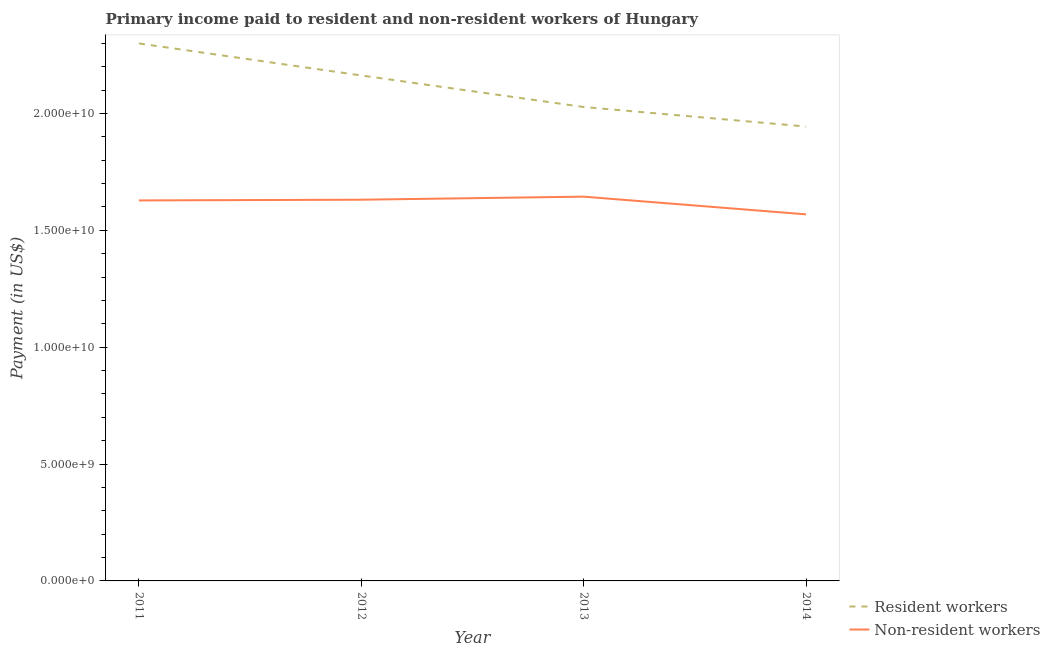Does the line corresponding to payment made to non-resident workers intersect with the line corresponding to payment made to resident workers?
Provide a succinct answer. No. What is the payment made to resident workers in 2011?
Provide a short and direct response. 2.30e+1. Across all years, what is the maximum payment made to resident workers?
Provide a succinct answer. 2.30e+1. Across all years, what is the minimum payment made to resident workers?
Keep it short and to the point. 1.94e+1. In which year was the payment made to resident workers maximum?
Your answer should be compact. 2011. In which year was the payment made to resident workers minimum?
Give a very brief answer. 2014. What is the total payment made to resident workers in the graph?
Give a very brief answer. 8.43e+1. What is the difference between the payment made to resident workers in 2012 and that in 2013?
Keep it short and to the point. 1.35e+09. What is the difference between the payment made to non-resident workers in 2014 and the payment made to resident workers in 2012?
Offer a very short reply. -5.94e+09. What is the average payment made to resident workers per year?
Provide a succinct answer. 2.11e+1. In the year 2014, what is the difference between the payment made to resident workers and payment made to non-resident workers?
Keep it short and to the point. 3.76e+09. What is the ratio of the payment made to non-resident workers in 2013 to that in 2014?
Give a very brief answer. 1.05. What is the difference between the highest and the second highest payment made to non-resident workers?
Offer a terse response. 1.30e+08. What is the difference between the highest and the lowest payment made to resident workers?
Offer a terse response. 3.56e+09. Is the sum of the payment made to resident workers in 2013 and 2014 greater than the maximum payment made to non-resident workers across all years?
Your answer should be compact. Yes. Is the payment made to resident workers strictly greater than the payment made to non-resident workers over the years?
Ensure brevity in your answer.  Yes. Is the payment made to resident workers strictly less than the payment made to non-resident workers over the years?
Your response must be concise. No. How many lines are there?
Give a very brief answer. 2. What is the difference between two consecutive major ticks on the Y-axis?
Offer a terse response. 5.00e+09. Does the graph contain any zero values?
Ensure brevity in your answer.  No. Does the graph contain grids?
Give a very brief answer. No. How are the legend labels stacked?
Offer a very short reply. Vertical. What is the title of the graph?
Offer a terse response. Primary income paid to resident and non-resident workers of Hungary. Does "Central government" appear as one of the legend labels in the graph?
Give a very brief answer. No. What is the label or title of the X-axis?
Provide a succinct answer. Year. What is the label or title of the Y-axis?
Offer a terse response. Payment (in US$). What is the Payment (in US$) of Resident workers in 2011?
Your answer should be very brief. 2.30e+1. What is the Payment (in US$) of Non-resident workers in 2011?
Your answer should be very brief. 1.63e+1. What is the Payment (in US$) in Resident workers in 2012?
Give a very brief answer. 2.16e+1. What is the Payment (in US$) in Non-resident workers in 2012?
Offer a terse response. 1.63e+1. What is the Payment (in US$) in Resident workers in 2013?
Provide a succinct answer. 2.03e+1. What is the Payment (in US$) of Non-resident workers in 2013?
Your response must be concise. 1.64e+1. What is the Payment (in US$) in Resident workers in 2014?
Offer a very short reply. 1.94e+1. What is the Payment (in US$) of Non-resident workers in 2014?
Offer a very short reply. 1.57e+1. Across all years, what is the maximum Payment (in US$) of Resident workers?
Your answer should be very brief. 2.30e+1. Across all years, what is the maximum Payment (in US$) of Non-resident workers?
Keep it short and to the point. 1.64e+1. Across all years, what is the minimum Payment (in US$) in Resident workers?
Provide a short and direct response. 1.94e+1. Across all years, what is the minimum Payment (in US$) of Non-resident workers?
Ensure brevity in your answer.  1.57e+1. What is the total Payment (in US$) in Resident workers in the graph?
Your answer should be compact. 8.43e+1. What is the total Payment (in US$) of Non-resident workers in the graph?
Your answer should be compact. 6.47e+1. What is the difference between the Payment (in US$) of Resident workers in 2011 and that in 2012?
Make the answer very short. 1.37e+09. What is the difference between the Payment (in US$) of Non-resident workers in 2011 and that in 2012?
Your answer should be compact. -3.10e+07. What is the difference between the Payment (in US$) of Resident workers in 2011 and that in 2013?
Offer a very short reply. 2.72e+09. What is the difference between the Payment (in US$) of Non-resident workers in 2011 and that in 2013?
Your answer should be very brief. -1.61e+08. What is the difference between the Payment (in US$) in Resident workers in 2011 and that in 2014?
Give a very brief answer. 3.56e+09. What is the difference between the Payment (in US$) in Non-resident workers in 2011 and that in 2014?
Keep it short and to the point. 5.96e+08. What is the difference between the Payment (in US$) of Resident workers in 2012 and that in 2013?
Offer a terse response. 1.35e+09. What is the difference between the Payment (in US$) in Non-resident workers in 2012 and that in 2013?
Your answer should be very brief. -1.30e+08. What is the difference between the Payment (in US$) in Resident workers in 2012 and that in 2014?
Your answer should be very brief. 2.19e+09. What is the difference between the Payment (in US$) of Non-resident workers in 2012 and that in 2014?
Your response must be concise. 6.27e+08. What is the difference between the Payment (in US$) of Resident workers in 2013 and that in 2014?
Ensure brevity in your answer.  8.36e+08. What is the difference between the Payment (in US$) of Non-resident workers in 2013 and that in 2014?
Keep it short and to the point. 7.57e+08. What is the difference between the Payment (in US$) of Resident workers in 2011 and the Payment (in US$) of Non-resident workers in 2012?
Give a very brief answer. 6.69e+09. What is the difference between the Payment (in US$) of Resident workers in 2011 and the Payment (in US$) of Non-resident workers in 2013?
Keep it short and to the point. 6.56e+09. What is the difference between the Payment (in US$) of Resident workers in 2011 and the Payment (in US$) of Non-resident workers in 2014?
Your response must be concise. 7.31e+09. What is the difference between the Payment (in US$) in Resident workers in 2012 and the Payment (in US$) in Non-resident workers in 2013?
Offer a very short reply. 5.19e+09. What is the difference between the Payment (in US$) of Resident workers in 2012 and the Payment (in US$) of Non-resident workers in 2014?
Give a very brief answer. 5.94e+09. What is the difference between the Payment (in US$) in Resident workers in 2013 and the Payment (in US$) in Non-resident workers in 2014?
Make the answer very short. 4.59e+09. What is the average Payment (in US$) in Resident workers per year?
Your answer should be compact. 2.11e+1. What is the average Payment (in US$) of Non-resident workers per year?
Offer a very short reply. 1.62e+1. In the year 2011, what is the difference between the Payment (in US$) in Resident workers and Payment (in US$) in Non-resident workers?
Provide a short and direct response. 6.72e+09. In the year 2012, what is the difference between the Payment (in US$) in Resident workers and Payment (in US$) in Non-resident workers?
Ensure brevity in your answer.  5.32e+09. In the year 2013, what is the difference between the Payment (in US$) in Resident workers and Payment (in US$) in Non-resident workers?
Give a very brief answer. 3.84e+09. In the year 2014, what is the difference between the Payment (in US$) of Resident workers and Payment (in US$) of Non-resident workers?
Give a very brief answer. 3.76e+09. What is the ratio of the Payment (in US$) of Resident workers in 2011 to that in 2012?
Provide a short and direct response. 1.06. What is the ratio of the Payment (in US$) of Non-resident workers in 2011 to that in 2012?
Make the answer very short. 1. What is the ratio of the Payment (in US$) in Resident workers in 2011 to that in 2013?
Give a very brief answer. 1.13. What is the ratio of the Payment (in US$) of Non-resident workers in 2011 to that in 2013?
Ensure brevity in your answer.  0.99. What is the ratio of the Payment (in US$) of Resident workers in 2011 to that in 2014?
Your answer should be very brief. 1.18. What is the ratio of the Payment (in US$) of Non-resident workers in 2011 to that in 2014?
Offer a terse response. 1.04. What is the ratio of the Payment (in US$) in Resident workers in 2012 to that in 2013?
Your answer should be compact. 1.07. What is the ratio of the Payment (in US$) in Resident workers in 2012 to that in 2014?
Your answer should be very brief. 1.11. What is the ratio of the Payment (in US$) in Resident workers in 2013 to that in 2014?
Your response must be concise. 1.04. What is the ratio of the Payment (in US$) of Non-resident workers in 2013 to that in 2014?
Your answer should be compact. 1.05. What is the difference between the highest and the second highest Payment (in US$) of Resident workers?
Your response must be concise. 1.37e+09. What is the difference between the highest and the second highest Payment (in US$) of Non-resident workers?
Your answer should be very brief. 1.30e+08. What is the difference between the highest and the lowest Payment (in US$) in Resident workers?
Your response must be concise. 3.56e+09. What is the difference between the highest and the lowest Payment (in US$) of Non-resident workers?
Offer a terse response. 7.57e+08. 